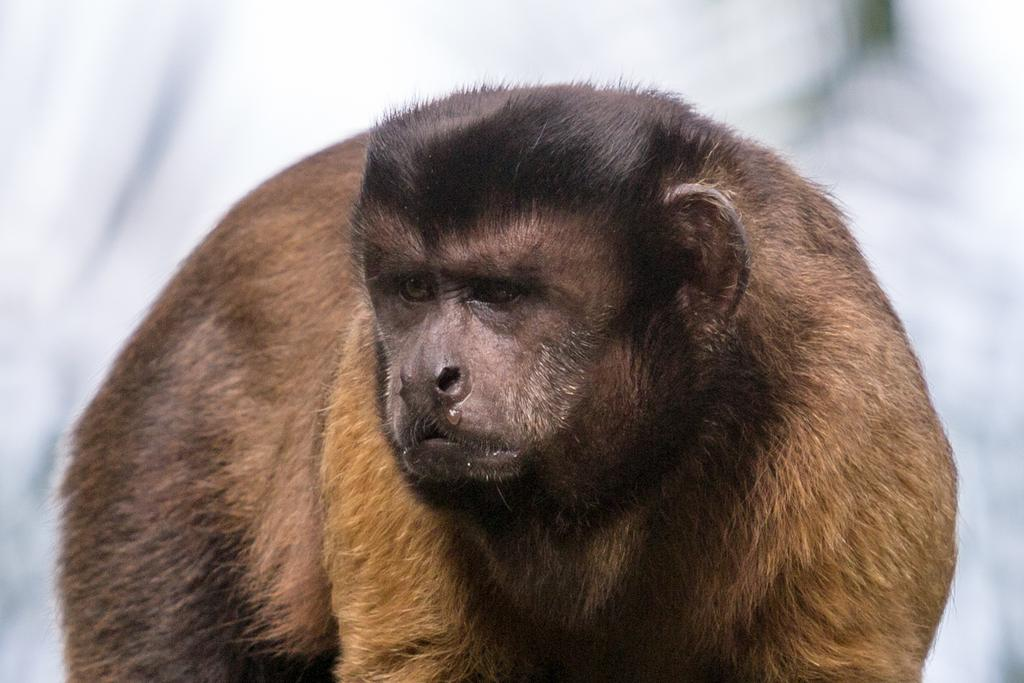What type of animal is in the image? There is an ape in the image. Can you describe the background of the image? The background of the image is blurred. How many wheels can be seen on the ape in the image? There are no wheels present on the ape in the image, as apes do not have wheels. 